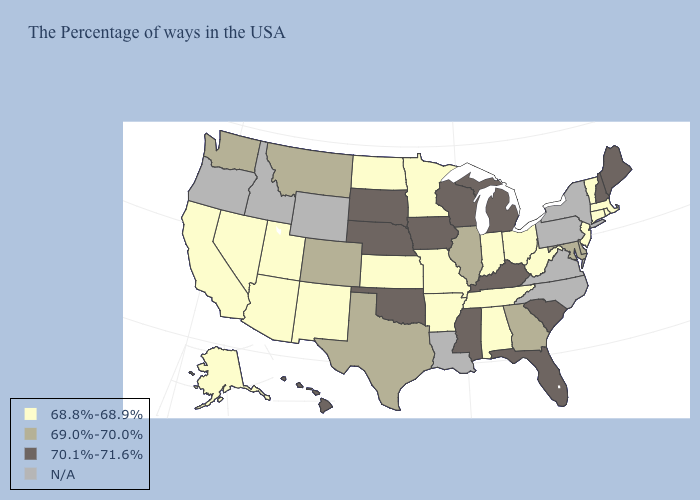Name the states that have a value in the range N/A?
Quick response, please. New York, Pennsylvania, Virginia, North Carolina, Louisiana, Wyoming, Idaho, Oregon. Which states have the lowest value in the MidWest?
Short answer required. Ohio, Indiana, Missouri, Minnesota, Kansas, North Dakota. Among the states that border North Carolina , which have the highest value?
Be succinct. South Carolina. Name the states that have a value in the range 68.8%-68.9%?
Be succinct. Massachusetts, Rhode Island, Vermont, Connecticut, New Jersey, West Virginia, Ohio, Indiana, Alabama, Tennessee, Missouri, Arkansas, Minnesota, Kansas, North Dakota, New Mexico, Utah, Arizona, Nevada, California, Alaska. What is the lowest value in the South?
Answer briefly. 68.8%-68.9%. Among the states that border Virginia , which have the highest value?
Quick response, please. Kentucky. What is the value of Connecticut?
Concise answer only. 68.8%-68.9%. What is the highest value in states that border Florida?
Short answer required. 69.0%-70.0%. Name the states that have a value in the range 68.8%-68.9%?
Give a very brief answer. Massachusetts, Rhode Island, Vermont, Connecticut, New Jersey, West Virginia, Ohio, Indiana, Alabama, Tennessee, Missouri, Arkansas, Minnesota, Kansas, North Dakota, New Mexico, Utah, Arizona, Nevada, California, Alaska. Among the states that border Texas , which have the highest value?
Answer briefly. Oklahoma. Name the states that have a value in the range 69.0%-70.0%?
Be succinct. Delaware, Maryland, Georgia, Illinois, Texas, Colorado, Montana, Washington. Does the first symbol in the legend represent the smallest category?
Keep it brief. Yes. What is the lowest value in the USA?
Be succinct. 68.8%-68.9%. 